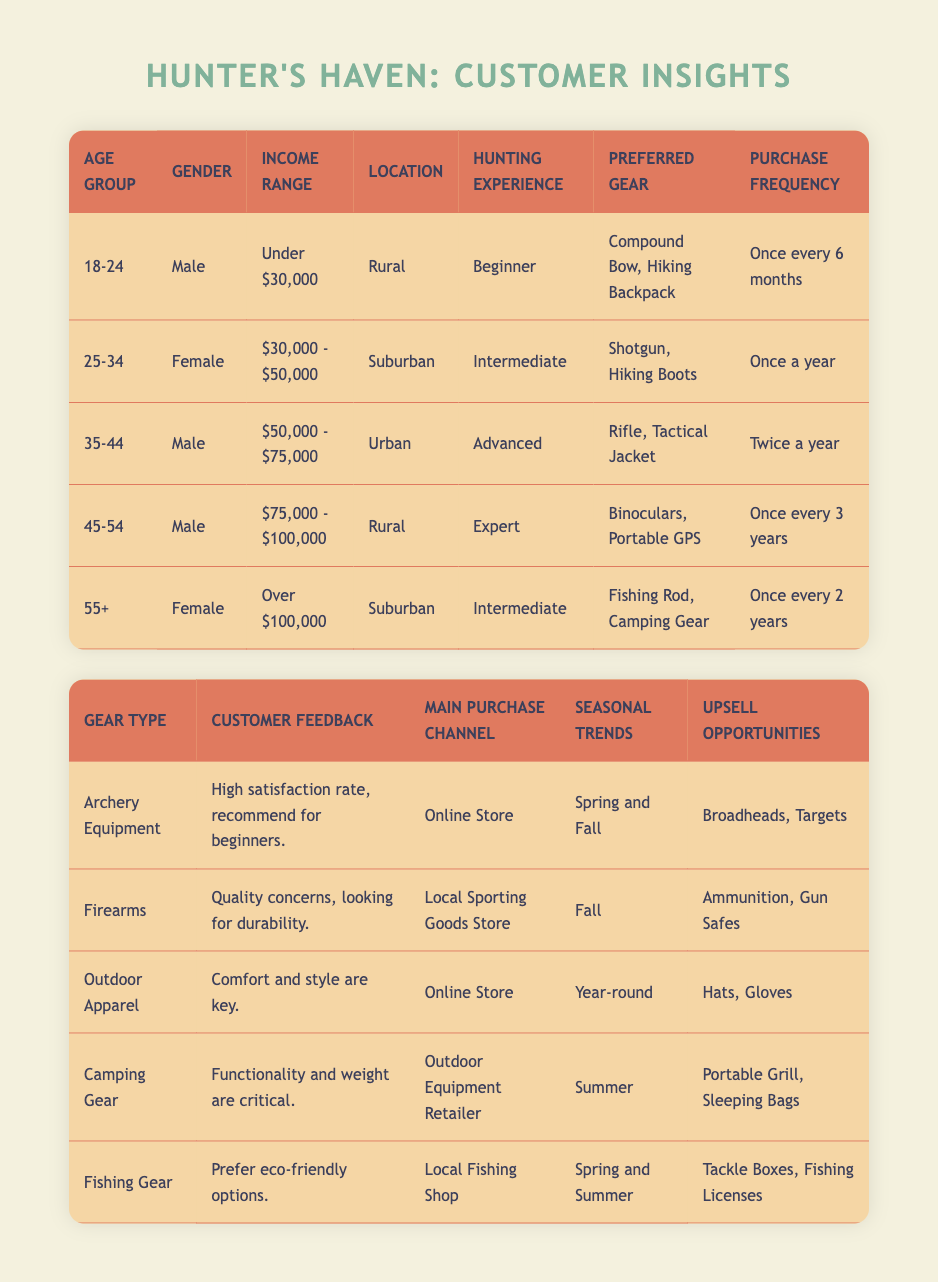What is the preferred gear for customers aged 35-44? The table indicates that the preferred gear for the age group 35-44 includes "Rifle" and "Tactical Jacket." This information can be found in the respective row for that age group.
Answer: Rifle, Tactical Jacket Which purchasing frequency is associated with individuals aged 55 and older? According to the table, customers aged 55 and older have a purchase frequency of "Once every 2 years," as per the entry in their category.
Answer: Once every 2 years Are all rural customers male? The table shows two rural customers: one aged 18-24 who is male and one aged 45-54 who is also male. There are no rural female customers in the data. Thus, the statement is true.
Answer: Yes What is the average income range of customers in the age group 25-34? The income range for the 25-34 age group is "$30,000 - $50,000," which encompasses a range but does not allow for a precise numerical average. It can be interpreted as approximately $40,000.
Answer: $40,000 (approximate) What is the main purchase channel for camping gear? The table specifies that the main purchase channel for camping gear is "Outdoor Equipment Retailer," which is directly listed in the respective row for camping gear.
Answer: Outdoor Equipment Retailer How many years do expert hunters usually purchase gear? The table indicates that expert hunters in the 45-54 age group have a purchase frequency of "Once every 3 years." This applies specifically to the individuals identified as experts.
Answer: Once every 3 years What is the correlation between customer income and preferred gear types? Examining the data, higher income is generally associated with more expensive gear types; for instance, the expert group (high income) prefers binoculars and GPS while the beginner group (low income) prefers more basic gear like a compound bow and hiking backpack. This suggests that higher income correlates with the preference for advanced gear types.
Answer: Higher income correlates with more expensive gear Can intermediate hunters be found in both suburban and urban locations? The table shows that intermediate hunters appear in the suburban location (ages 25-34) and also in the 55+ age group, confirming that they can be found in competing locations but not in urban.
Answer: No 